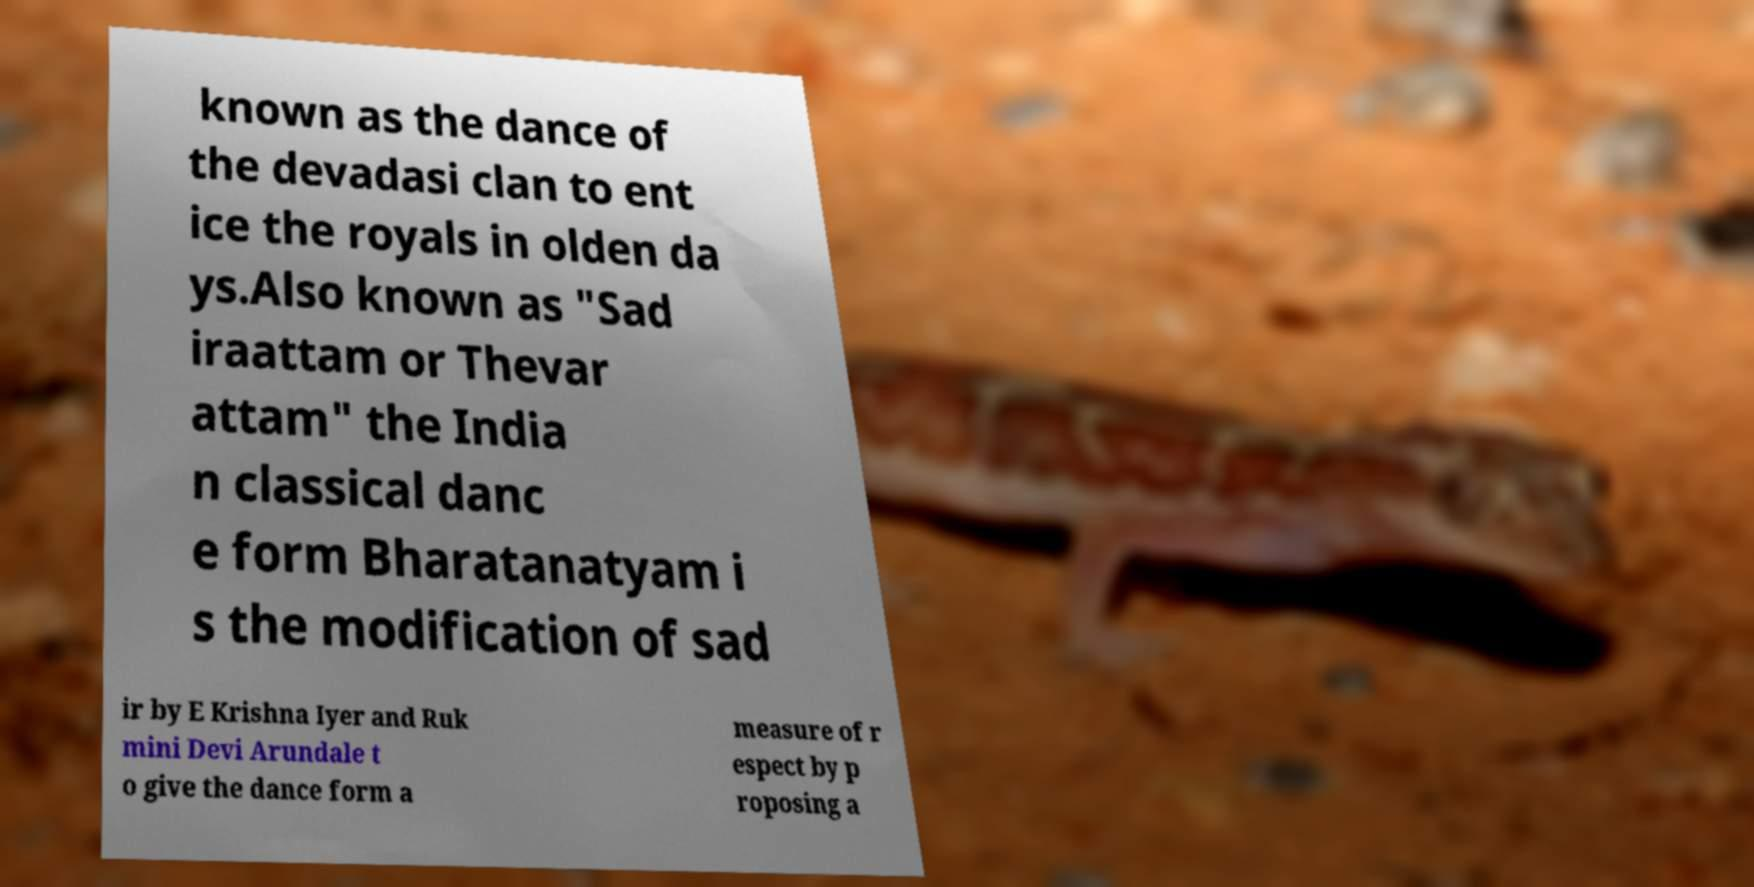Could you extract and type out the text from this image? known as the dance of the devadasi clan to ent ice the royals in olden da ys.Also known as "Sad iraattam or Thevar attam" the India n classical danc e form Bharatanatyam i s the modification of sad ir by E Krishna Iyer and Ruk mini Devi Arundale t o give the dance form a measure of r espect by p roposing a 